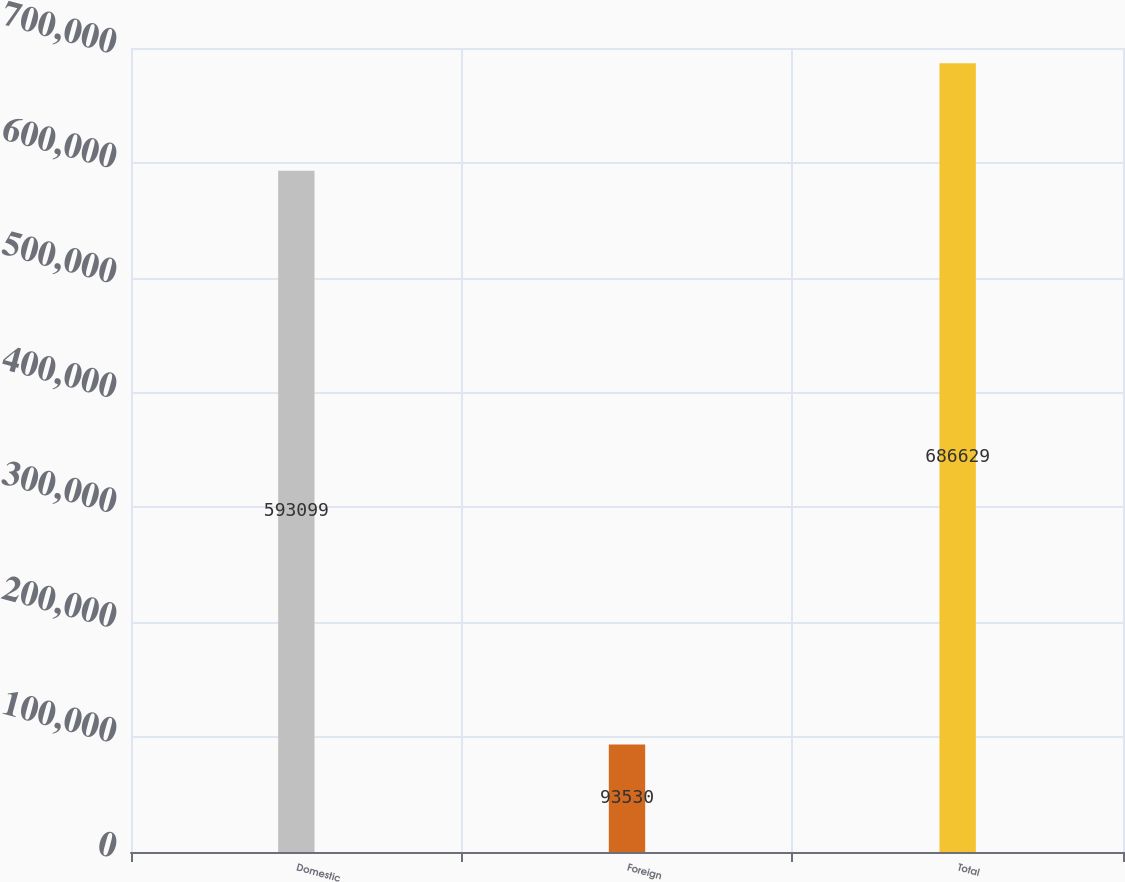Convert chart. <chart><loc_0><loc_0><loc_500><loc_500><bar_chart><fcel>Domestic<fcel>Foreign<fcel>Total<nl><fcel>593099<fcel>93530<fcel>686629<nl></chart> 